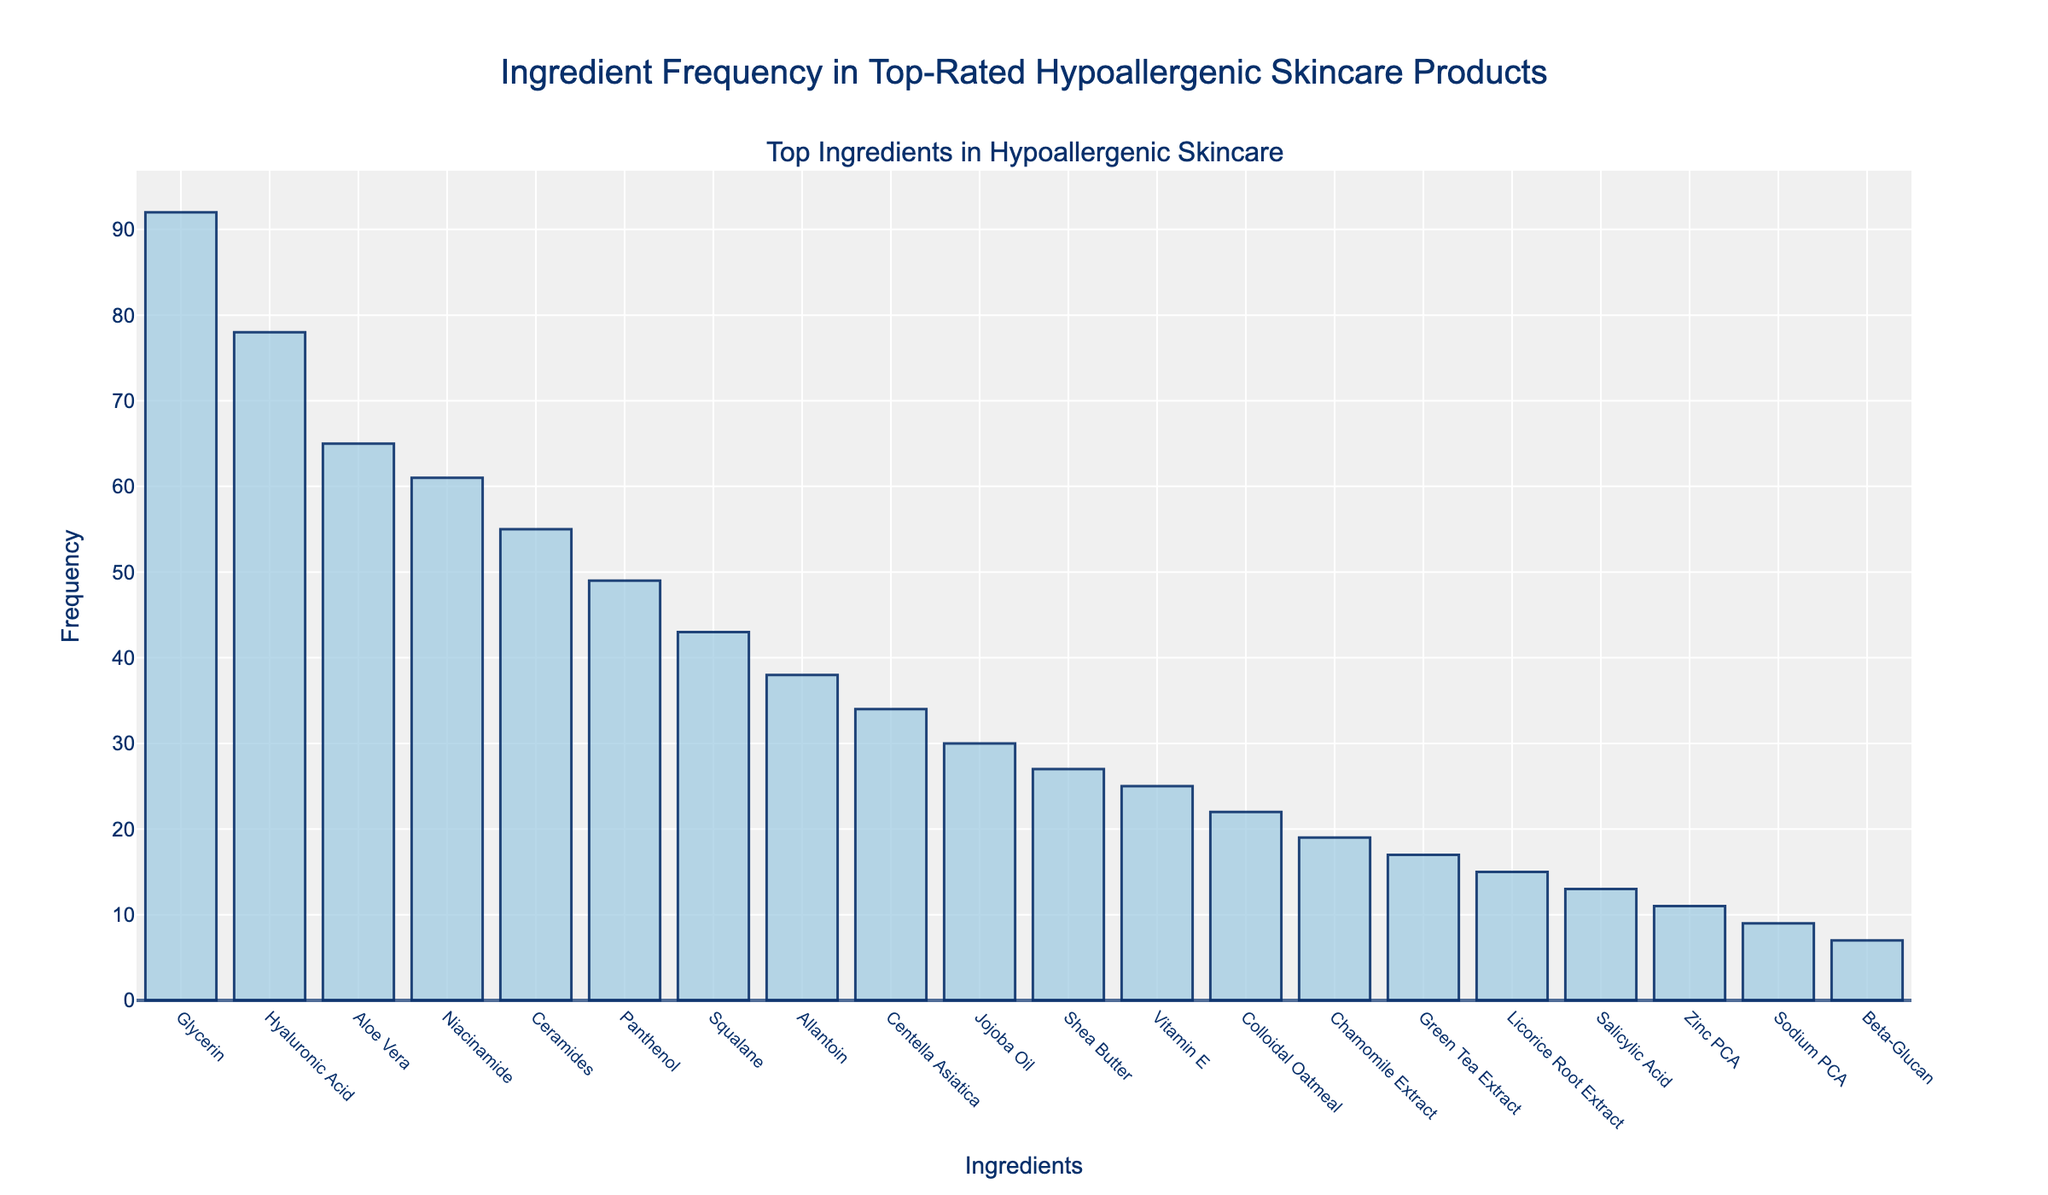What's the most frequent ingredient in top-rated hypoallergenic skincare products? The tallest bar in the chart represents the most frequent ingredient. The label on the x-axis for this bar is "Glycerin" and the corresponding frequency on the y-axis is 92.
Answer: Glycerin Which ingredient has a frequency of 49? Referring to the y-axis, find the bar that aligns with 49. The ingredient label corresponding to this bar on the x-axis is "Panthenol."
Answer: Panthenol How many ingredients have a frequency greater than 50? Count all the bars on the graph where the y-axis value is greater than 50. These ingredients (Glycerin, Hyaluronic Acid, Aloe Vera, Niacinamide, and Ceramides) total 5.
Answer: 5 What's the difference in frequency between Hyaluronic Acid and Niacinamide? Hyaluronic Acid has a frequency of 78, and Niacinamide has a frequency of 61. Subtract 61 from 78 to get the difference.
Answer: 17 Which has a higher frequency: Centella Asiatica or Shea Butter? By comparing the heights of the bars, Centella Asiatica (34) is taller than Shea Butter (27), indicating a higher frequency.
Answer: Centella Asiatica What is the combined frequency of Allantoin, Chamomile Extract, and Squalane? Sum the frequencies of Allantoin (38), Chamomile Extract (19), and Squalane (43). The total is 38 + 19 + 43 = 100.
Answer: 100 Which ingredient has the lowest frequency? The shortest bar in the chart represents the lowest frequency, corresponding to the ingredient "Beta-Glucan" with a frequency of 7.
Answer: Beta-Glucan How many ingredients have a frequency between 20 and 40, inclusive? Count the bars that fall within the range of 20 to 40 on the y-axis. These ingredients (Allantoin, Centella Asiatica, Jojoba Oil, Shea Butter, Vitamin E, and Colloidal Oatmeal) total 6.
Answer: 6 By how much does the frequency of Glycerin exceed the frequency of Sodium PCA? Glycerin has a frequency of 92 and Sodium PCA has 9. Subtract 9 from 92 to find the difference.
Answer: 83 